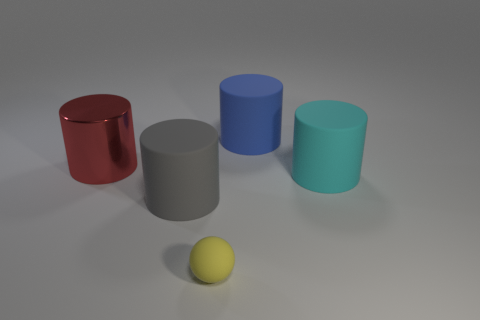Subtract all gray cylinders. How many cylinders are left? 3 Add 5 large blue cylinders. How many objects exist? 10 Subtract all cyan cylinders. How many cylinders are left? 3 Subtract all cylinders. How many objects are left? 1 Add 2 cylinders. How many cylinders are left? 6 Add 5 gray shiny things. How many gray shiny things exist? 5 Subtract 0 green cylinders. How many objects are left? 5 Subtract all purple cylinders. Subtract all purple blocks. How many cylinders are left? 4 Subtract all small gray matte objects. Subtract all cylinders. How many objects are left? 1 